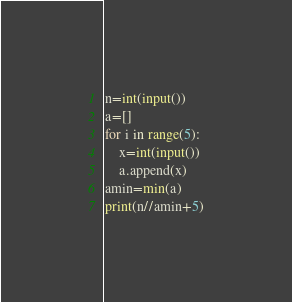<code> <loc_0><loc_0><loc_500><loc_500><_Python_>n=int(input())
a=[]
for i in range(5):
    x=int(input())
    a.append(x)
amin=min(a)
print(n//amin+5)
</code> 